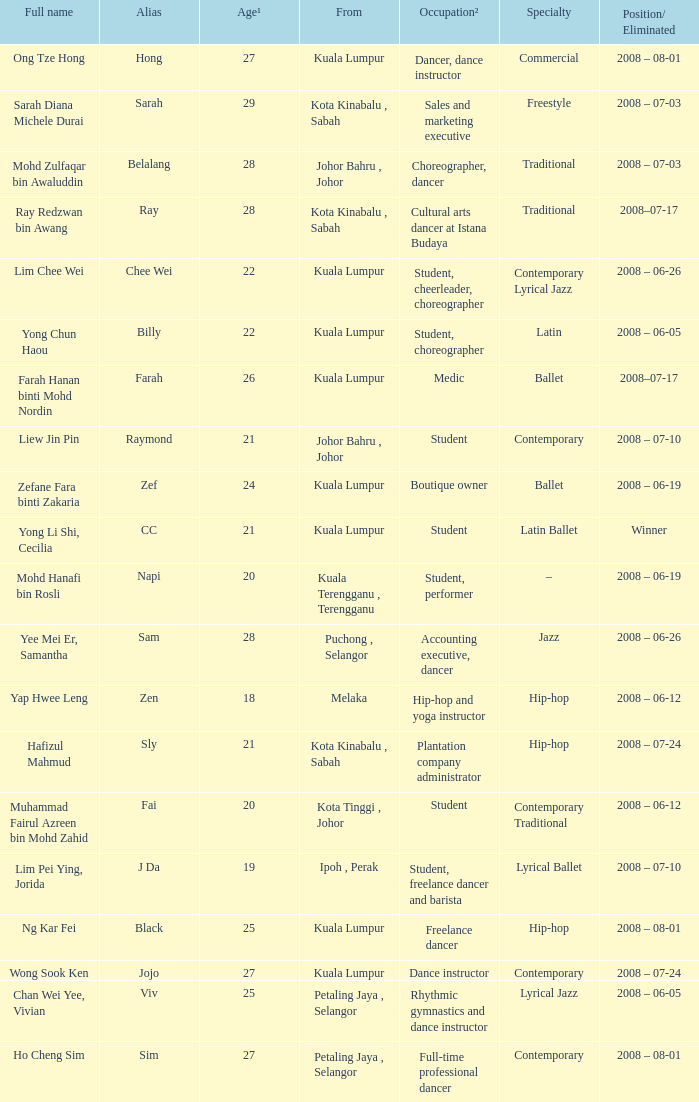What is Full Name, when Age¹ is "20", and when Occupation² is "Student"? Muhammad Fairul Azreen bin Mohd Zahid. Can you give me this table as a dict? {'header': ['Full name', 'Alias', 'Age¹', 'From', 'Occupation²', 'Specialty', 'Position/ Eliminated'], 'rows': [['Ong Tze Hong', 'Hong', '27', 'Kuala Lumpur', 'Dancer, dance instructor', 'Commercial', '2008 – 08-01'], ['Sarah Diana Michele Durai', 'Sarah', '29', 'Kota Kinabalu , Sabah', 'Sales and marketing executive', 'Freestyle', '2008 – 07-03'], ['Mohd Zulfaqar bin Awaluddin', 'Belalang', '28', 'Johor Bahru , Johor', 'Choreographer, dancer', 'Traditional', '2008 – 07-03'], ['Ray Redzwan bin Awang', 'Ray', '28', 'Kota Kinabalu , Sabah', 'Cultural arts dancer at Istana Budaya', 'Traditional', '2008–07-17'], ['Lim Chee Wei', 'Chee Wei', '22', 'Kuala Lumpur', 'Student, cheerleader, choreographer', 'Contemporary Lyrical Jazz', '2008 – 06-26'], ['Yong Chun Haou', 'Billy', '22', 'Kuala Lumpur', 'Student, choreographer', 'Latin', '2008 – 06-05'], ['Farah Hanan binti Mohd Nordin', 'Farah', '26', 'Kuala Lumpur', 'Medic', 'Ballet', '2008–07-17'], ['Liew Jin Pin', 'Raymond', '21', 'Johor Bahru , Johor', 'Student', 'Contemporary', '2008 – 07-10'], ['Zefane Fara binti Zakaria', 'Zef', '24', 'Kuala Lumpur', 'Boutique owner', 'Ballet', '2008 – 06-19'], ['Yong Li Shi, Cecilia', 'CC', '21', 'Kuala Lumpur', 'Student', 'Latin Ballet', 'Winner'], ['Mohd Hanafi bin Rosli', 'Napi', '20', 'Kuala Terengganu , Terengganu', 'Student, performer', '–', '2008 – 06-19'], ['Yee Mei Er, Samantha', 'Sam', '28', 'Puchong , Selangor', 'Accounting executive, dancer', 'Jazz', '2008 – 06-26'], ['Yap Hwee Leng', 'Zen', '18', 'Melaka', 'Hip-hop and yoga instructor', 'Hip-hop', '2008 – 06-12'], ['Hafizul Mahmud', 'Sly', '21', 'Kota Kinabalu , Sabah', 'Plantation company administrator', 'Hip-hop', '2008 – 07-24'], ['Muhammad Fairul Azreen bin Mohd Zahid', 'Fai', '20', 'Kota Tinggi , Johor', 'Student', 'Contemporary Traditional', '2008 – 06-12'], ['Lim Pei Ying, Jorida', 'J Da', '19', 'Ipoh , Perak', 'Student, freelance dancer and barista', 'Lyrical Ballet', '2008 – 07-10'], ['Ng Kar Fei', 'Black', '25', 'Kuala Lumpur', 'Freelance dancer', 'Hip-hop', '2008 – 08-01'], ['Wong Sook Ken', 'Jojo', '27', 'Kuala Lumpur', 'Dance instructor', 'Contemporary', '2008 – 07-24'], ['Chan Wei Yee, Vivian', 'Viv', '25', 'Petaling Jaya , Selangor', 'Rhythmic gymnastics and dance instructor', 'Lyrical Jazz', '2008 – 06-05'], ['Ho Cheng Sim', 'Sim', '27', 'Petaling Jaya , Selangor', 'Full-time professional dancer', 'Contemporary', '2008 – 08-01']]} 